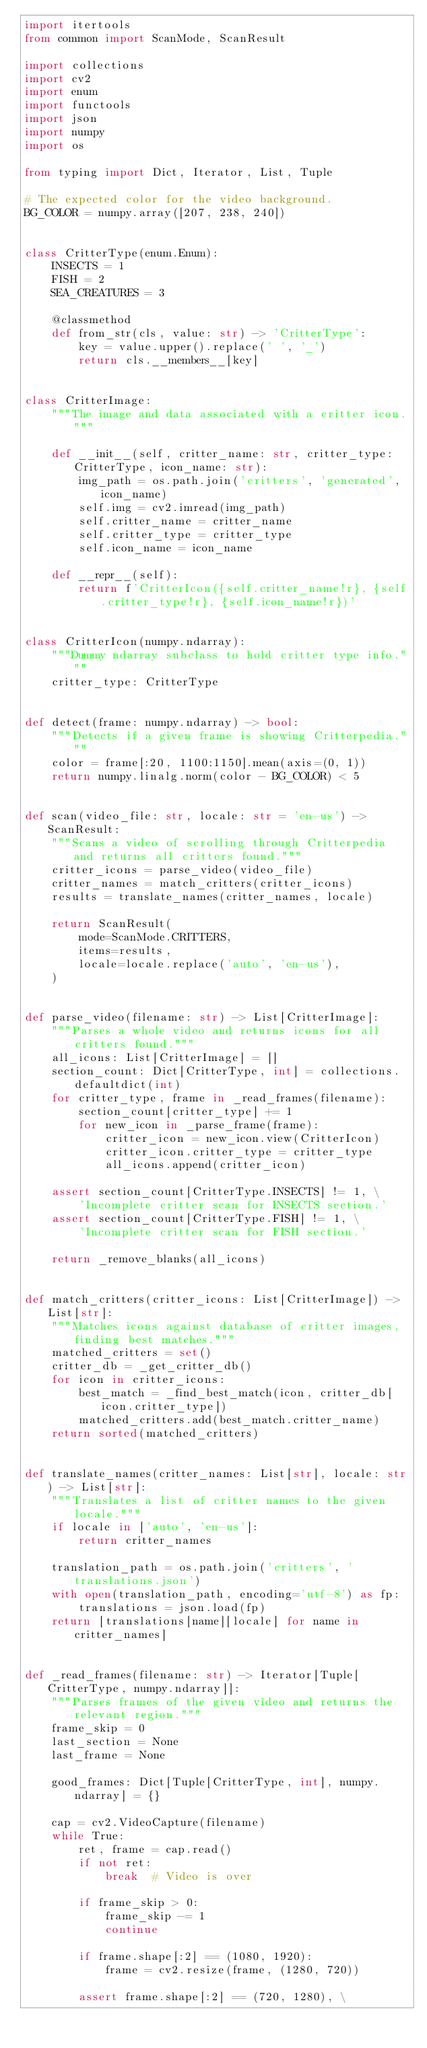<code> <loc_0><loc_0><loc_500><loc_500><_Python_>import itertools
from common import ScanMode, ScanResult

import collections
import cv2
import enum
import functools
import json
import numpy
import os

from typing import Dict, Iterator, List, Tuple

# The expected color for the video background.
BG_COLOR = numpy.array([207, 238, 240])


class CritterType(enum.Enum):
    INSECTS = 1
    FISH = 2
    SEA_CREATURES = 3

    @classmethod
    def from_str(cls, value: str) -> 'CritterType':
        key = value.upper().replace(' ', '_')
        return cls.__members__[key]


class CritterImage:
    """The image and data associated with a critter icon."""

    def __init__(self, critter_name: str, critter_type: CritterType, icon_name: str):
        img_path = os.path.join('critters', 'generated', icon_name)
        self.img = cv2.imread(img_path)
        self.critter_name = critter_name
        self.critter_type = critter_type
        self.icon_name = icon_name

    def __repr__(self):
        return f'CritterIcon({self.critter_name!r}, {self.critter_type!r}, {self.icon_name!r})'


class CritterIcon(numpy.ndarray):
    """Dummy ndarray subclass to hold critter type info."""
    critter_type: CritterType


def detect(frame: numpy.ndarray) -> bool:
    """Detects if a given frame is showing Critterpedia."""
    color = frame[:20, 1100:1150].mean(axis=(0, 1))
    return numpy.linalg.norm(color - BG_COLOR) < 5


def scan(video_file: str, locale: str = 'en-us') -> ScanResult:
    """Scans a video of scrolling through Critterpedia and returns all critters found."""
    critter_icons = parse_video(video_file)
    critter_names = match_critters(critter_icons)
    results = translate_names(critter_names, locale)

    return ScanResult(
        mode=ScanMode.CRITTERS,
        items=results,
        locale=locale.replace('auto', 'en-us'),
    )


def parse_video(filename: str) -> List[CritterImage]:
    """Parses a whole video and returns icons for all critters found."""
    all_icons: List[CritterImage] = []
    section_count: Dict[CritterType, int] = collections.defaultdict(int)
    for critter_type, frame in _read_frames(filename):
        section_count[critter_type] += 1
        for new_icon in _parse_frame(frame):
            critter_icon = new_icon.view(CritterIcon)
            critter_icon.critter_type = critter_type
            all_icons.append(critter_icon)

    assert section_count[CritterType.INSECTS] != 1, \
        'Incomplete critter scan for INSECTS section.'
    assert section_count[CritterType.FISH] != 1, \
        'Incomplete critter scan for FISH section.'

    return _remove_blanks(all_icons)


def match_critters(critter_icons: List[CritterImage]) -> List[str]:
    """Matches icons against database of critter images, finding best matches."""
    matched_critters = set()
    critter_db = _get_critter_db()
    for icon in critter_icons:
        best_match = _find_best_match(icon, critter_db[icon.critter_type])
        matched_critters.add(best_match.critter_name)
    return sorted(matched_critters)


def translate_names(critter_names: List[str], locale: str) -> List[str]:
    """Translates a list of critter names to the given locale."""
    if locale in ['auto', 'en-us']:
        return critter_names

    translation_path = os.path.join('critters', 'translations.json')
    with open(translation_path, encoding='utf-8') as fp:
        translations = json.load(fp)
    return [translations[name][locale] for name in critter_names]


def _read_frames(filename: str) -> Iterator[Tuple[CritterType, numpy.ndarray]]:
    """Parses frames of the given video and returns the relevant region."""
    frame_skip = 0
    last_section = None
    last_frame = None

    good_frames: Dict[Tuple[CritterType, int], numpy.ndarray] = {}

    cap = cv2.VideoCapture(filename)
    while True:
        ret, frame = cap.read()
        if not ret:
            break  # Video is over

        if frame_skip > 0:
            frame_skip -= 1
            continue

        if frame.shape[:2] == (1080, 1920):
            frame = cv2.resize(frame, (1280, 720))

        assert frame.shape[:2] == (720, 1280), \</code> 